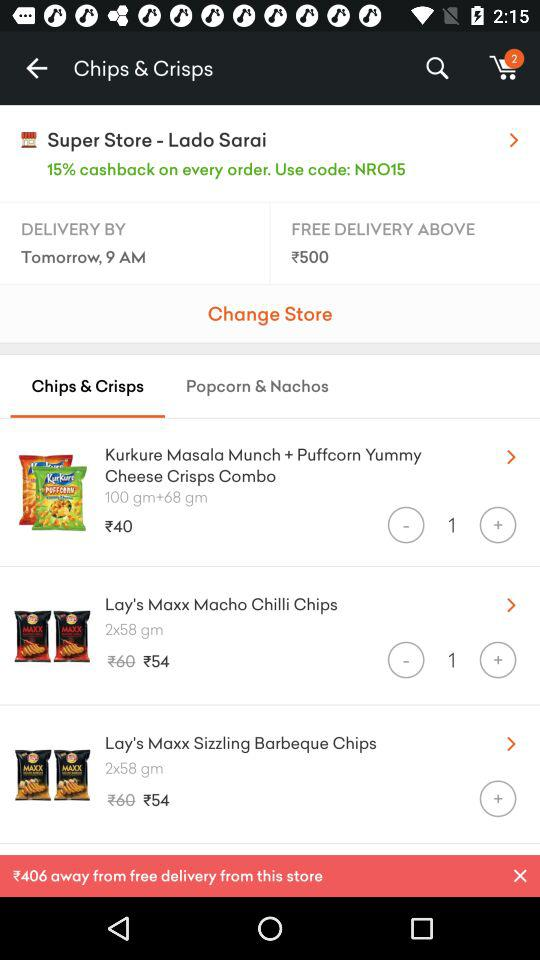Which tab is selected? The selected tab is "Chips & Crisps". 